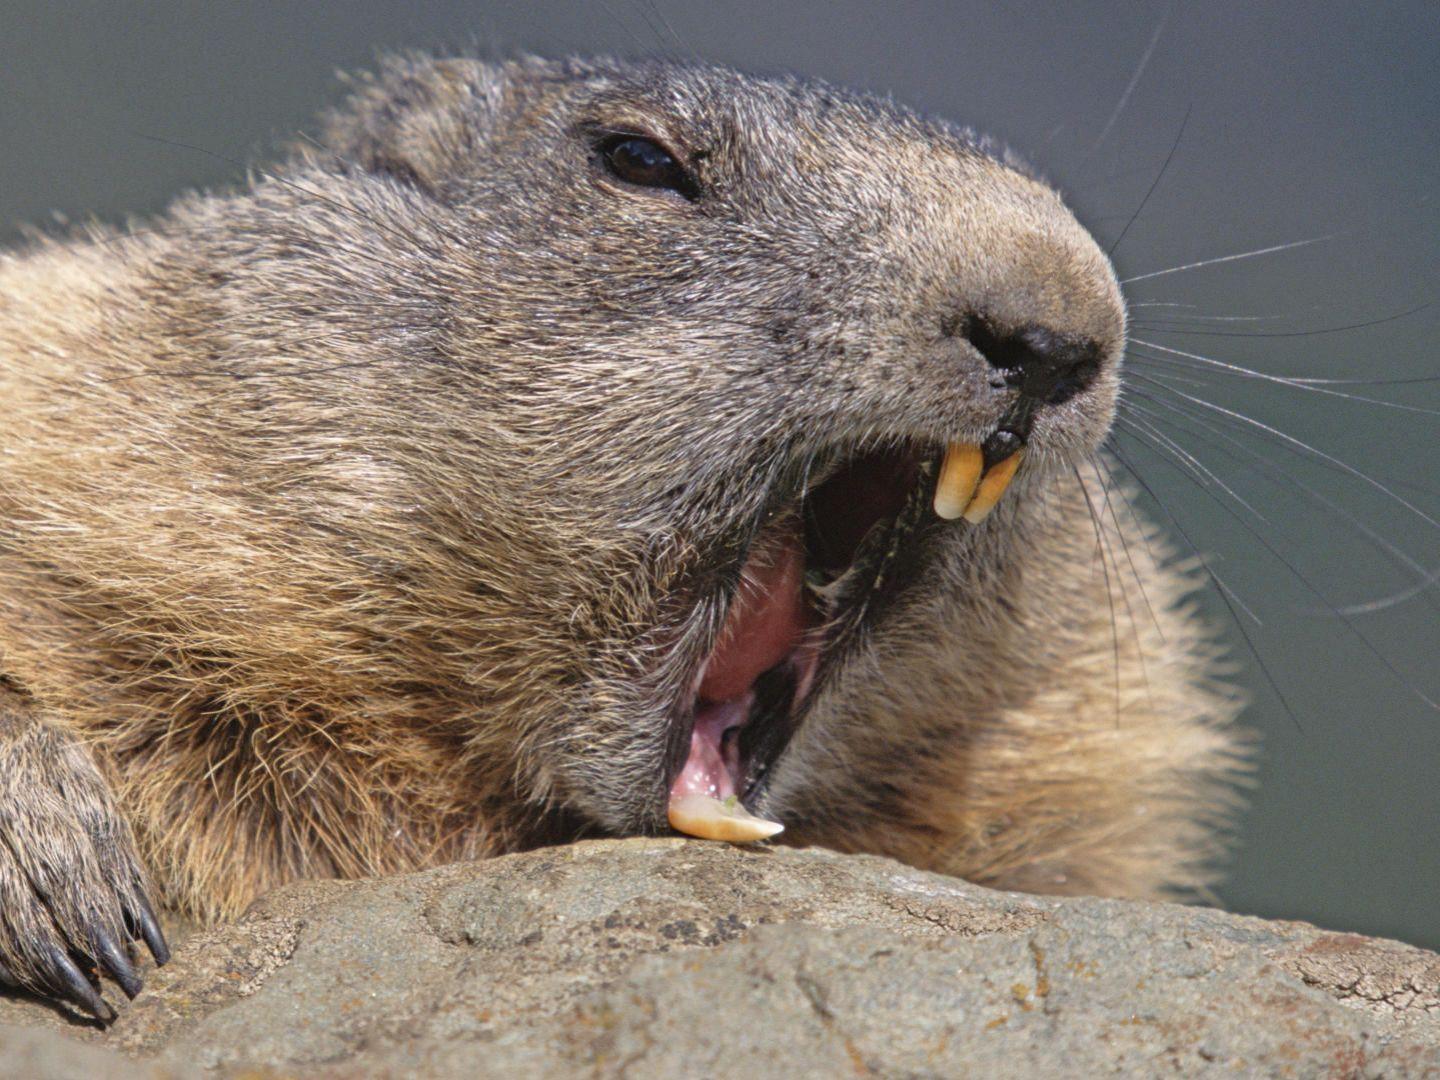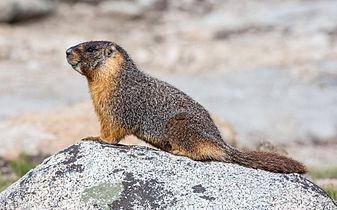The first image is the image on the left, the second image is the image on the right. Assess this claim about the two images: "the animal on the right image is facing left". Correct or not? Answer yes or no. Yes. 